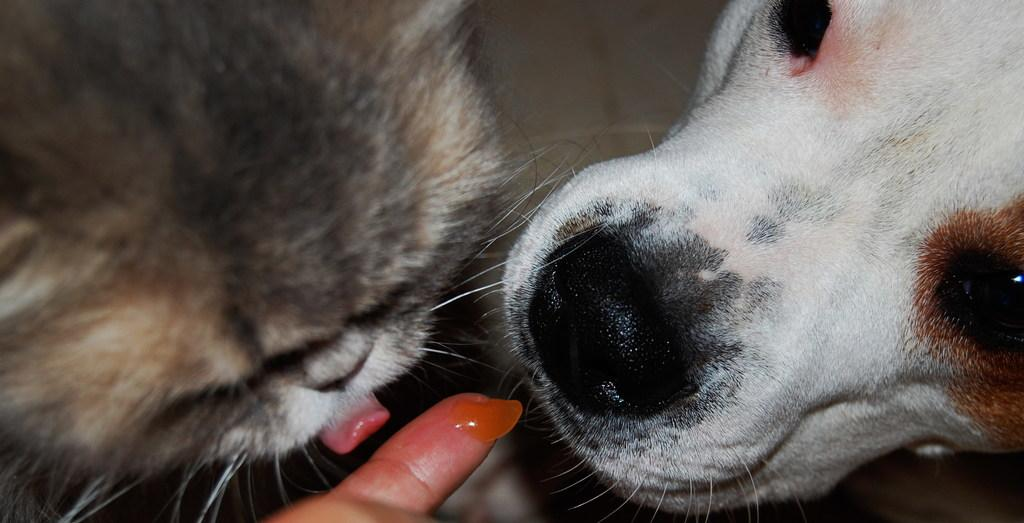What type of animals are present in the image? There are dogs in the image. Can you describe any other elements in the image besides the dogs? A person's finger is visible at the bottom of the image, and there is a wall in the background. What type of curtain can be seen hanging from the wall in the image? There is no curtain present in the image; only a wall is visible in the background. What does the voice of the yak sound like in the image? There is no yak present in the image, so it is not possible to determine the sound of its voice. 